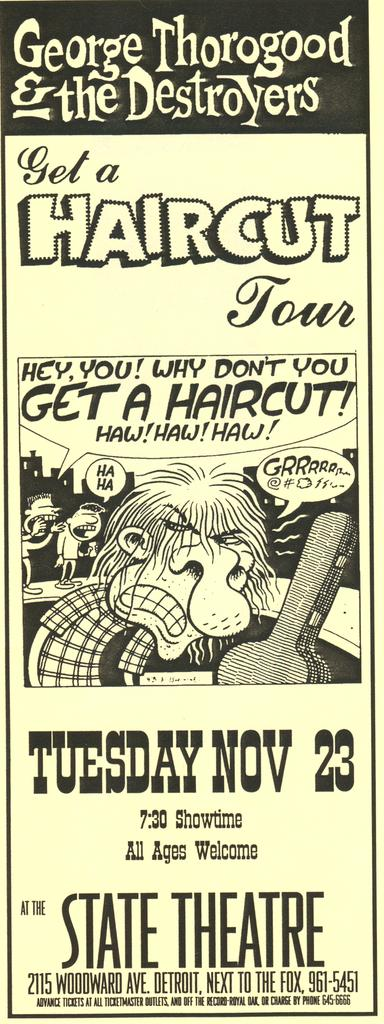<image>
Share a concise interpretation of the image provided. a poster that invites you to get a haircut  on nov 23. 